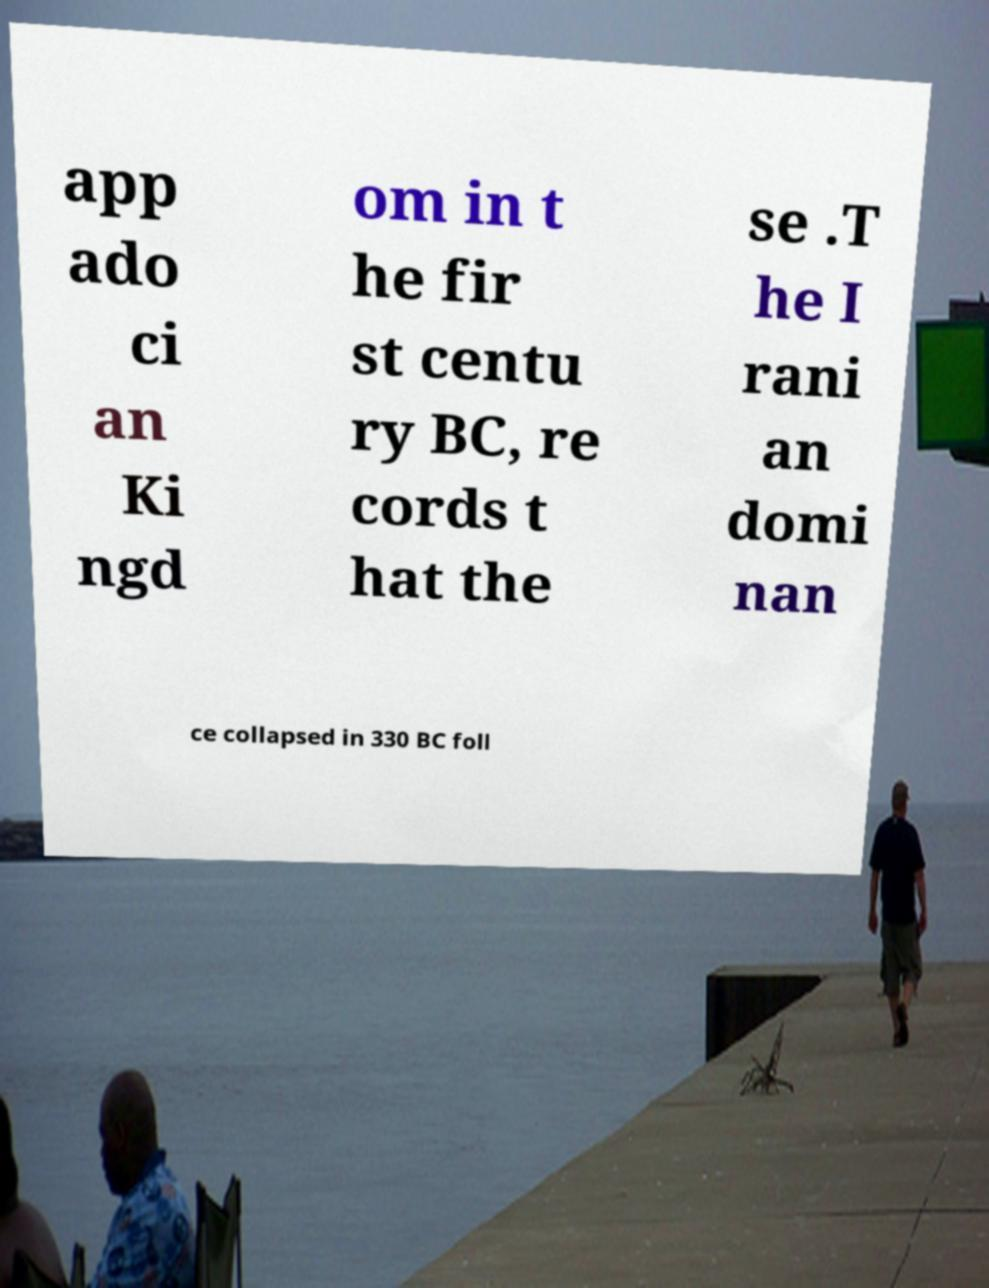Please read and relay the text visible in this image. What does it say? app ado ci an Ki ngd om in t he fir st centu ry BC, re cords t hat the se .T he I rani an domi nan ce collapsed in 330 BC foll 